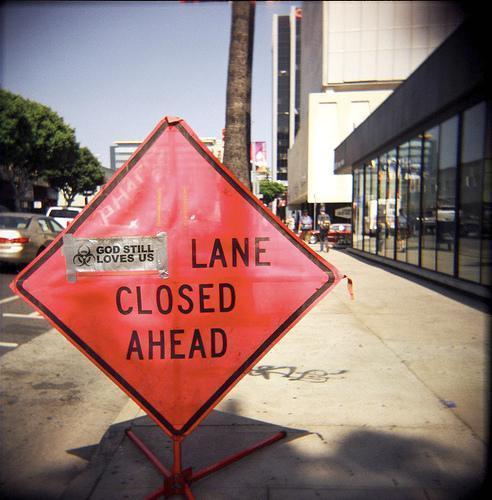How was something added to this sign most recently?
Answer the question by selecting the correct answer among the 4 following choices.
Options: Nailed, tape, ironed on, painted. Tape. 